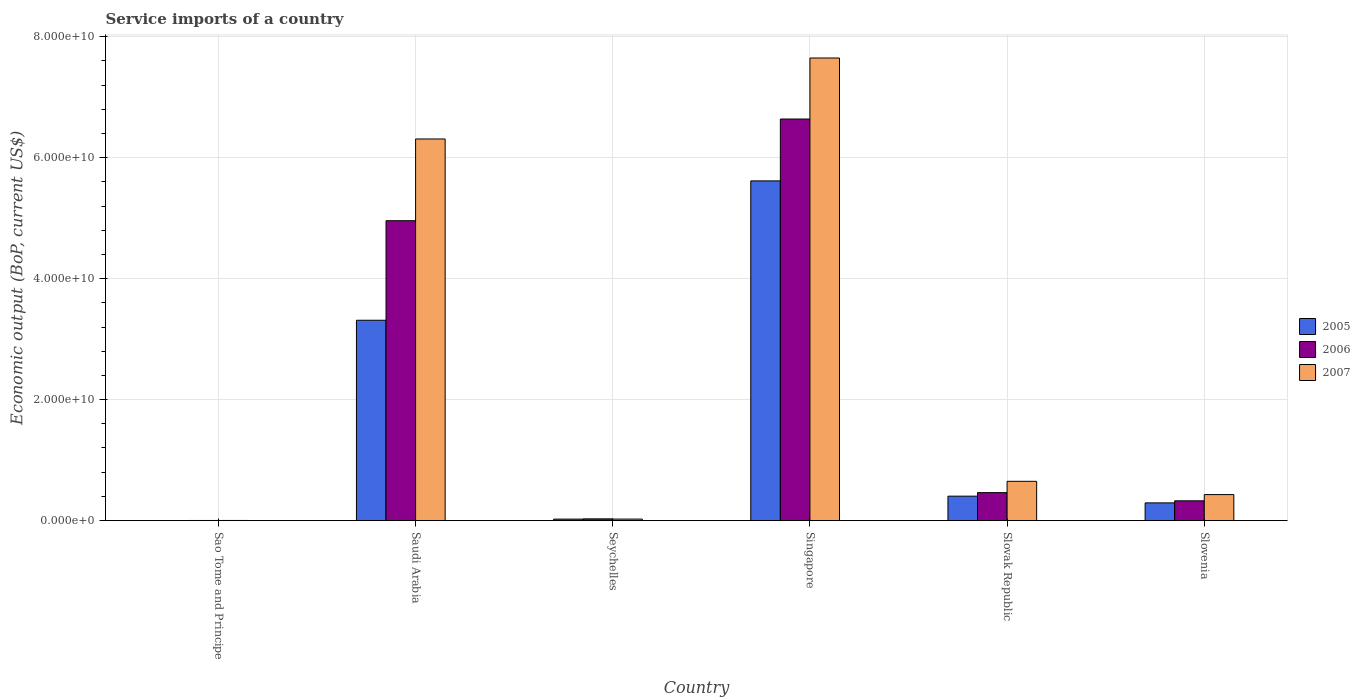How many groups of bars are there?
Ensure brevity in your answer.  6. Are the number of bars on each tick of the X-axis equal?
Give a very brief answer. Yes. What is the label of the 6th group of bars from the left?
Make the answer very short. Slovenia. In how many cases, is the number of bars for a given country not equal to the number of legend labels?
Offer a very short reply. 0. What is the service imports in 2005 in Seychelles?
Provide a succinct answer. 2.40e+08. Across all countries, what is the maximum service imports in 2005?
Ensure brevity in your answer.  5.62e+1. Across all countries, what is the minimum service imports in 2007?
Provide a succinct answer. 1.87e+07. In which country was the service imports in 2006 maximum?
Provide a succinct answer. Singapore. In which country was the service imports in 2006 minimum?
Provide a succinct answer. Sao Tome and Principe. What is the total service imports in 2006 in the graph?
Your response must be concise. 1.24e+11. What is the difference between the service imports in 2006 in Seychelles and that in Slovak Republic?
Your answer should be very brief. -4.34e+09. What is the difference between the service imports in 2007 in Slovak Republic and the service imports in 2005 in Seychelles?
Provide a succinct answer. 6.25e+09. What is the average service imports in 2005 per country?
Give a very brief answer. 1.61e+1. What is the difference between the service imports of/in 2005 and service imports of/in 2006 in Saudi Arabia?
Ensure brevity in your answer.  -1.65e+1. What is the ratio of the service imports in 2006 in Saudi Arabia to that in Slovenia?
Provide a short and direct response. 15.18. Is the difference between the service imports in 2005 in Saudi Arabia and Singapore greater than the difference between the service imports in 2006 in Saudi Arabia and Singapore?
Provide a succinct answer. No. What is the difference between the highest and the second highest service imports in 2005?
Make the answer very short. -2.91e+1. What is the difference between the highest and the lowest service imports in 2006?
Ensure brevity in your answer.  6.64e+1. What does the 1st bar from the right in Slovenia represents?
Provide a short and direct response. 2007. Are all the bars in the graph horizontal?
Offer a very short reply. No. How many countries are there in the graph?
Provide a short and direct response. 6. What is the difference between two consecutive major ticks on the Y-axis?
Your answer should be very brief. 2.00e+1. Are the values on the major ticks of Y-axis written in scientific E-notation?
Your answer should be very brief. Yes. Does the graph contain any zero values?
Offer a very short reply. No. How many legend labels are there?
Provide a succinct answer. 3. How are the legend labels stacked?
Keep it short and to the point. Vertical. What is the title of the graph?
Give a very brief answer. Service imports of a country. Does "1994" appear as one of the legend labels in the graph?
Provide a short and direct response. No. What is the label or title of the Y-axis?
Provide a succinct answer. Economic output (BoP, current US$). What is the Economic output (BoP, current US$) in 2005 in Sao Tome and Principe?
Provide a short and direct response. 1.11e+07. What is the Economic output (BoP, current US$) of 2006 in Sao Tome and Principe?
Ensure brevity in your answer.  1.78e+07. What is the Economic output (BoP, current US$) in 2007 in Sao Tome and Principe?
Offer a terse response. 1.87e+07. What is the Economic output (BoP, current US$) in 2005 in Saudi Arabia?
Provide a succinct answer. 3.31e+1. What is the Economic output (BoP, current US$) of 2006 in Saudi Arabia?
Make the answer very short. 4.96e+1. What is the Economic output (BoP, current US$) in 2007 in Saudi Arabia?
Provide a short and direct response. 6.31e+1. What is the Economic output (BoP, current US$) of 2005 in Seychelles?
Your answer should be very brief. 2.40e+08. What is the Economic output (BoP, current US$) of 2006 in Seychelles?
Make the answer very short. 2.83e+08. What is the Economic output (BoP, current US$) in 2007 in Seychelles?
Your answer should be compact. 2.47e+08. What is the Economic output (BoP, current US$) in 2005 in Singapore?
Make the answer very short. 5.62e+1. What is the Economic output (BoP, current US$) of 2006 in Singapore?
Provide a succinct answer. 6.64e+1. What is the Economic output (BoP, current US$) of 2007 in Singapore?
Keep it short and to the point. 7.65e+1. What is the Economic output (BoP, current US$) in 2005 in Slovak Republic?
Provide a succinct answer. 4.04e+09. What is the Economic output (BoP, current US$) in 2006 in Slovak Republic?
Give a very brief answer. 4.62e+09. What is the Economic output (BoP, current US$) of 2007 in Slovak Republic?
Make the answer very short. 6.49e+09. What is the Economic output (BoP, current US$) in 2005 in Slovenia?
Give a very brief answer. 2.93e+09. What is the Economic output (BoP, current US$) in 2006 in Slovenia?
Make the answer very short. 3.27e+09. What is the Economic output (BoP, current US$) of 2007 in Slovenia?
Your answer should be very brief. 4.30e+09. Across all countries, what is the maximum Economic output (BoP, current US$) of 2005?
Ensure brevity in your answer.  5.62e+1. Across all countries, what is the maximum Economic output (BoP, current US$) of 2006?
Your answer should be compact. 6.64e+1. Across all countries, what is the maximum Economic output (BoP, current US$) of 2007?
Offer a terse response. 7.65e+1. Across all countries, what is the minimum Economic output (BoP, current US$) in 2005?
Ensure brevity in your answer.  1.11e+07. Across all countries, what is the minimum Economic output (BoP, current US$) in 2006?
Give a very brief answer. 1.78e+07. Across all countries, what is the minimum Economic output (BoP, current US$) of 2007?
Ensure brevity in your answer.  1.87e+07. What is the total Economic output (BoP, current US$) of 2005 in the graph?
Offer a terse response. 9.65e+1. What is the total Economic output (BoP, current US$) in 2006 in the graph?
Make the answer very short. 1.24e+11. What is the total Economic output (BoP, current US$) of 2007 in the graph?
Give a very brief answer. 1.51e+11. What is the difference between the Economic output (BoP, current US$) in 2005 in Sao Tome and Principe and that in Saudi Arabia?
Make the answer very short. -3.31e+1. What is the difference between the Economic output (BoP, current US$) in 2006 in Sao Tome and Principe and that in Saudi Arabia?
Your response must be concise. -4.96e+1. What is the difference between the Economic output (BoP, current US$) of 2007 in Sao Tome and Principe and that in Saudi Arabia?
Offer a terse response. -6.31e+1. What is the difference between the Economic output (BoP, current US$) of 2005 in Sao Tome and Principe and that in Seychelles?
Ensure brevity in your answer.  -2.29e+08. What is the difference between the Economic output (BoP, current US$) in 2006 in Sao Tome and Principe and that in Seychelles?
Ensure brevity in your answer.  -2.65e+08. What is the difference between the Economic output (BoP, current US$) in 2007 in Sao Tome and Principe and that in Seychelles?
Your response must be concise. -2.28e+08. What is the difference between the Economic output (BoP, current US$) in 2005 in Sao Tome and Principe and that in Singapore?
Provide a succinct answer. -5.62e+1. What is the difference between the Economic output (BoP, current US$) in 2006 in Sao Tome and Principe and that in Singapore?
Give a very brief answer. -6.64e+1. What is the difference between the Economic output (BoP, current US$) of 2007 in Sao Tome and Principe and that in Singapore?
Your answer should be very brief. -7.65e+1. What is the difference between the Economic output (BoP, current US$) in 2005 in Sao Tome and Principe and that in Slovak Republic?
Provide a short and direct response. -4.02e+09. What is the difference between the Economic output (BoP, current US$) of 2006 in Sao Tome and Principe and that in Slovak Republic?
Offer a terse response. -4.60e+09. What is the difference between the Economic output (BoP, current US$) of 2007 in Sao Tome and Principe and that in Slovak Republic?
Offer a terse response. -6.47e+09. What is the difference between the Economic output (BoP, current US$) in 2005 in Sao Tome and Principe and that in Slovenia?
Your answer should be very brief. -2.91e+09. What is the difference between the Economic output (BoP, current US$) of 2006 in Sao Tome and Principe and that in Slovenia?
Your response must be concise. -3.25e+09. What is the difference between the Economic output (BoP, current US$) in 2007 in Sao Tome and Principe and that in Slovenia?
Keep it short and to the point. -4.28e+09. What is the difference between the Economic output (BoP, current US$) of 2005 in Saudi Arabia and that in Seychelles?
Your answer should be compact. 3.29e+1. What is the difference between the Economic output (BoP, current US$) in 2006 in Saudi Arabia and that in Seychelles?
Ensure brevity in your answer.  4.93e+1. What is the difference between the Economic output (BoP, current US$) in 2007 in Saudi Arabia and that in Seychelles?
Your answer should be compact. 6.28e+1. What is the difference between the Economic output (BoP, current US$) in 2005 in Saudi Arabia and that in Singapore?
Keep it short and to the point. -2.30e+1. What is the difference between the Economic output (BoP, current US$) of 2006 in Saudi Arabia and that in Singapore?
Give a very brief answer. -1.68e+1. What is the difference between the Economic output (BoP, current US$) in 2007 in Saudi Arabia and that in Singapore?
Offer a terse response. -1.34e+1. What is the difference between the Economic output (BoP, current US$) of 2005 in Saudi Arabia and that in Slovak Republic?
Provide a succinct answer. 2.91e+1. What is the difference between the Economic output (BoP, current US$) of 2006 in Saudi Arabia and that in Slovak Republic?
Offer a terse response. 4.50e+1. What is the difference between the Economic output (BoP, current US$) in 2007 in Saudi Arabia and that in Slovak Republic?
Make the answer very short. 5.66e+1. What is the difference between the Economic output (BoP, current US$) of 2005 in Saudi Arabia and that in Slovenia?
Your response must be concise. 3.02e+1. What is the difference between the Economic output (BoP, current US$) of 2006 in Saudi Arabia and that in Slovenia?
Your answer should be compact. 4.63e+1. What is the difference between the Economic output (BoP, current US$) of 2007 in Saudi Arabia and that in Slovenia?
Provide a short and direct response. 5.88e+1. What is the difference between the Economic output (BoP, current US$) in 2005 in Seychelles and that in Singapore?
Ensure brevity in your answer.  -5.59e+1. What is the difference between the Economic output (BoP, current US$) in 2006 in Seychelles and that in Singapore?
Your answer should be very brief. -6.61e+1. What is the difference between the Economic output (BoP, current US$) of 2007 in Seychelles and that in Singapore?
Provide a succinct answer. -7.62e+1. What is the difference between the Economic output (BoP, current US$) in 2005 in Seychelles and that in Slovak Republic?
Give a very brief answer. -3.80e+09. What is the difference between the Economic output (BoP, current US$) of 2006 in Seychelles and that in Slovak Republic?
Your response must be concise. -4.34e+09. What is the difference between the Economic output (BoP, current US$) of 2007 in Seychelles and that in Slovak Republic?
Your answer should be very brief. -6.24e+09. What is the difference between the Economic output (BoP, current US$) of 2005 in Seychelles and that in Slovenia?
Offer a very short reply. -2.69e+09. What is the difference between the Economic output (BoP, current US$) of 2006 in Seychelles and that in Slovenia?
Give a very brief answer. -2.98e+09. What is the difference between the Economic output (BoP, current US$) in 2007 in Seychelles and that in Slovenia?
Offer a terse response. -4.05e+09. What is the difference between the Economic output (BoP, current US$) in 2005 in Singapore and that in Slovak Republic?
Offer a very short reply. 5.21e+1. What is the difference between the Economic output (BoP, current US$) in 2006 in Singapore and that in Slovak Republic?
Give a very brief answer. 6.18e+1. What is the difference between the Economic output (BoP, current US$) in 2007 in Singapore and that in Slovak Republic?
Make the answer very short. 7.00e+1. What is the difference between the Economic output (BoP, current US$) of 2005 in Singapore and that in Slovenia?
Keep it short and to the point. 5.32e+1. What is the difference between the Economic output (BoP, current US$) in 2006 in Singapore and that in Slovenia?
Ensure brevity in your answer.  6.31e+1. What is the difference between the Economic output (BoP, current US$) in 2007 in Singapore and that in Slovenia?
Keep it short and to the point. 7.22e+1. What is the difference between the Economic output (BoP, current US$) of 2005 in Slovak Republic and that in Slovenia?
Make the answer very short. 1.11e+09. What is the difference between the Economic output (BoP, current US$) in 2006 in Slovak Republic and that in Slovenia?
Your answer should be very brief. 1.35e+09. What is the difference between the Economic output (BoP, current US$) of 2007 in Slovak Republic and that in Slovenia?
Provide a succinct answer. 2.19e+09. What is the difference between the Economic output (BoP, current US$) in 2005 in Sao Tome and Principe and the Economic output (BoP, current US$) in 2006 in Saudi Arabia?
Offer a terse response. -4.96e+1. What is the difference between the Economic output (BoP, current US$) in 2005 in Sao Tome and Principe and the Economic output (BoP, current US$) in 2007 in Saudi Arabia?
Ensure brevity in your answer.  -6.31e+1. What is the difference between the Economic output (BoP, current US$) of 2006 in Sao Tome and Principe and the Economic output (BoP, current US$) of 2007 in Saudi Arabia?
Your response must be concise. -6.31e+1. What is the difference between the Economic output (BoP, current US$) of 2005 in Sao Tome and Principe and the Economic output (BoP, current US$) of 2006 in Seychelles?
Give a very brief answer. -2.72e+08. What is the difference between the Economic output (BoP, current US$) in 2005 in Sao Tome and Principe and the Economic output (BoP, current US$) in 2007 in Seychelles?
Give a very brief answer. -2.36e+08. What is the difference between the Economic output (BoP, current US$) in 2006 in Sao Tome and Principe and the Economic output (BoP, current US$) in 2007 in Seychelles?
Provide a succinct answer. -2.29e+08. What is the difference between the Economic output (BoP, current US$) of 2005 in Sao Tome and Principe and the Economic output (BoP, current US$) of 2006 in Singapore?
Offer a terse response. -6.64e+1. What is the difference between the Economic output (BoP, current US$) in 2005 in Sao Tome and Principe and the Economic output (BoP, current US$) in 2007 in Singapore?
Offer a very short reply. -7.65e+1. What is the difference between the Economic output (BoP, current US$) of 2006 in Sao Tome and Principe and the Economic output (BoP, current US$) of 2007 in Singapore?
Make the answer very short. -7.65e+1. What is the difference between the Economic output (BoP, current US$) in 2005 in Sao Tome and Principe and the Economic output (BoP, current US$) in 2006 in Slovak Republic?
Make the answer very short. -4.61e+09. What is the difference between the Economic output (BoP, current US$) in 2005 in Sao Tome and Principe and the Economic output (BoP, current US$) in 2007 in Slovak Republic?
Your answer should be very brief. -6.48e+09. What is the difference between the Economic output (BoP, current US$) of 2006 in Sao Tome and Principe and the Economic output (BoP, current US$) of 2007 in Slovak Republic?
Ensure brevity in your answer.  -6.47e+09. What is the difference between the Economic output (BoP, current US$) in 2005 in Sao Tome and Principe and the Economic output (BoP, current US$) in 2006 in Slovenia?
Give a very brief answer. -3.26e+09. What is the difference between the Economic output (BoP, current US$) in 2005 in Sao Tome and Principe and the Economic output (BoP, current US$) in 2007 in Slovenia?
Provide a succinct answer. -4.29e+09. What is the difference between the Economic output (BoP, current US$) of 2006 in Sao Tome and Principe and the Economic output (BoP, current US$) of 2007 in Slovenia?
Provide a succinct answer. -4.28e+09. What is the difference between the Economic output (BoP, current US$) in 2005 in Saudi Arabia and the Economic output (BoP, current US$) in 2006 in Seychelles?
Your answer should be compact. 3.28e+1. What is the difference between the Economic output (BoP, current US$) of 2005 in Saudi Arabia and the Economic output (BoP, current US$) of 2007 in Seychelles?
Your answer should be very brief. 3.29e+1. What is the difference between the Economic output (BoP, current US$) of 2006 in Saudi Arabia and the Economic output (BoP, current US$) of 2007 in Seychelles?
Give a very brief answer. 4.93e+1. What is the difference between the Economic output (BoP, current US$) in 2005 in Saudi Arabia and the Economic output (BoP, current US$) in 2006 in Singapore?
Your answer should be very brief. -3.33e+1. What is the difference between the Economic output (BoP, current US$) in 2005 in Saudi Arabia and the Economic output (BoP, current US$) in 2007 in Singapore?
Your response must be concise. -4.34e+1. What is the difference between the Economic output (BoP, current US$) in 2006 in Saudi Arabia and the Economic output (BoP, current US$) in 2007 in Singapore?
Keep it short and to the point. -2.69e+1. What is the difference between the Economic output (BoP, current US$) of 2005 in Saudi Arabia and the Economic output (BoP, current US$) of 2006 in Slovak Republic?
Give a very brief answer. 2.85e+1. What is the difference between the Economic output (BoP, current US$) of 2005 in Saudi Arabia and the Economic output (BoP, current US$) of 2007 in Slovak Republic?
Offer a very short reply. 2.66e+1. What is the difference between the Economic output (BoP, current US$) in 2006 in Saudi Arabia and the Economic output (BoP, current US$) in 2007 in Slovak Republic?
Your answer should be compact. 4.31e+1. What is the difference between the Economic output (BoP, current US$) in 2005 in Saudi Arabia and the Economic output (BoP, current US$) in 2006 in Slovenia?
Offer a very short reply. 2.99e+1. What is the difference between the Economic output (BoP, current US$) of 2005 in Saudi Arabia and the Economic output (BoP, current US$) of 2007 in Slovenia?
Offer a very short reply. 2.88e+1. What is the difference between the Economic output (BoP, current US$) in 2006 in Saudi Arabia and the Economic output (BoP, current US$) in 2007 in Slovenia?
Offer a terse response. 4.53e+1. What is the difference between the Economic output (BoP, current US$) of 2005 in Seychelles and the Economic output (BoP, current US$) of 2006 in Singapore?
Your answer should be compact. -6.62e+1. What is the difference between the Economic output (BoP, current US$) of 2005 in Seychelles and the Economic output (BoP, current US$) of 2007 in Singapore?
Offer a terse response. -7.62e+1. What is the difference between the Economic output (BoP, current US$) in 2006 in Seychelles and the Economic output (BoP, current US$) in 2007 in Singapore?
Offer a very short reply. -7.62e+1. What is the difference between the Economic output (BoP, current US$) in 2005 in Seychelles and the Economic output (BoP, current US$) in 2006 in Slovak Republic?
Give a very brief answer. -4.38e+09. What is the difference between the Economic output (BoP, current US$) of 2005 in Seychelles and the Economic output (BoP, current US$) of 2007 in Slovak Republic?
Your response must be concise. -6.25e+09. What is the difference between the Economic output (BoP, current US$) in 2006 in Seychelles and the Economic output (BoP, current US$) in 2007 in Slovak Republic?
Provide a short and direct response. -6.21e+09. What is the difference between the Economic output (BoP, current US$) in 2005 in Seychelles and the Economic output (BoP, current US$) in 2006 in Slovenia?
Provide a succinct answer. -3.03e+09. What is the difference between the Economic output (BoP, current US$) in 2005 in Seychelles and the Economic output (BoP, current US$) in 2007 in Slovenia?
Offer a terse response. -4.06e+09. What is the difference between the Economic output (BoP, current US$) of 2006 in Seychelles and the Economic output (BoP, current US$) of 2007 in Slovenia?
Keep it short and to the point. -4.01e+09. What is the difference between the Economic output (BoP, current US$) in 2005 in Singapore and the Economic output (BoP, current US$) in 2006 in Slovak Republic?
Make the answer very short. 5.15e+1. What is the difference between the Economic output (BoP, current US$) in 2005 in Singapore and the Economic output (BoP, current US$) in 2007 in Slovak Republic?
Provide a succinct answer. 4.97e+1. What is the difference between the Economic output (BoP, current US$) in 2006 in Singapore and the Economic output (BoP, current US$) in 2007 in Slovak Republic?
Make the answer very short. 5.99e+1. What is the difference between the Economic output (BoP, current US$) of 2005 in Singapore and the Economic output (BoP, current US$) of 2006 in Slovenia?
Your answer should be very brief. 5.29e+1. What is the difference between the Economic output (BoP, current US$) of 2005 in Singapore and the Economic output (BoP, current US$) of 2007 in Slovenia?
Provide a short and direct response. 5.19e+1. What is the difference between the Economic output (BoP, current US$) of 2006 in Singapore and the Economic output (BoP, current US$) of 2007 in Slovenia?
Provide a short and direct response. 6.21e+1. What is the difference between the Economic output (BoP, current US$) of 2005 in Slovak Republic and the Economic output (BoP, current US$) of 2006 in Slovenia?
Your answer should be very brief. 7.69e+08. What is the difference between the Economic output (BoP, current US$) in 2005 in Slovak Republic and the Economic output (BoP, current US$) in 2007 in Slovenia?
Ensure brevity in your answer.  -2.62e+08. What is the difference between the Economic output (BoP, current US$) of 2006 in Slovak Republic and the Economic output (BoP, current US$) of 2007 in Slovenia?
Your answer should be very brief. 3.23e+08. What is the average Economic output (BoP, current US$) in 2005 per country?
Make the answer very short. 1.61e+1. What is the average Economic output (BoP, current US$) in 2006 per country?
Your answer should be very brief. 2.07e+1. What is the average Economic output (BoP, current US$) in 2007 per country?
Offer a very short reply. 2.51e+1. What is the difference between the Economic output (BoP, current US$) of 2005 and Economic output (BoP, current US$) of 2006 in Sao Tome and Principe?
Offer a very short reply. -6.70e+06. What is the difference between the Economic output (BoP, current US$) in 2005 and Economic output (BoP, current US$) in 2007 in Sao Tome and Principe?
Offer a very short reply. -7.61e+06. What is the difference between the Economic output (BoP, current US$) in 2006 and Economic output (BoP, current US$) in 2007 in Sao Tome and Principe?
Give a very brief answer. -9.06e+05. What is the difference between the Economic output (BoP, current US$) in 2005 and Economic output (BoP, current US$) in 2006 in Saudi Arabia?
Give a very brief answer. -1.65e+1. What is the difference between the Economic output (BoP, current US$) in 2005 and Economic output (BoP, current US$) in 2007 in Saudi Arabia?
Give a very brief answer. -3.00e+1. What is the difference between the Economic output (BoP, current US$) in 2006 and Economic output (BoP, current US$) in 2007 in Saudi Arabia?
Make the answer very short. -1.35e+1. What is the difference between the Economic output (BoP, current US$) in 2005 and Economic output (BoP, current US$) in 2006 in Seychelles?
Your answer should be very brief. -4.24e+07. What is the difference between the Economic output (BoP, current US$) of 2005 and Economic output (BoP, current US$) of 2007 in Seychelles?
Your response must be concise. -6.43e+06. What is the difference between the Economic output (BoP, current US$) in 2006 and Economic output (BoP, current US$) in 2007 in Seychelles?
Offer a terse response. 3.60e+07. What is the difference between the Economic output (BoP, current US$) of 2005 and Economic output (BoP, current US$) of 2006 in Singapore?
Your answer should be compact. -1.02e+1. What is the difference between the Economic output (BoP, current US$) of 2005 and Economic output (BoP, current US$) of 2007 in Singapore?
Make the answer very short. -2.03e+1. What is the difference between the Economic output (BoP, current US$) of 2006 and Economic output (BoP, current US$) of 2007 in Singapore?
Keep it short and to the point. -1.01e+1. What is the difference between the Economic output (BoP, current US$) in 2005 and Economic output (BoP, current US$) in 2006 in Slovak Republic?
Offer a very short reply. -5.85e+08. What is the difference between the Economic output (BoP, current US$) in 2005 and Economic output (BoP, current US$) in 2007 in Slovak Republic?
Provide a succinct answer. -2.46e+09. What is the difference between the Economic output (BoP, current US$) in 2006 and Economic output (BoP, current US$) in 2007 in Slovak Republic?
Make the answer very short. -1.87e+09. What is the difference between the Economic output (BoP, current US$) in 2005 and Economic output (BoP, current US$) in 2006 in Slovenia?
Provide a succinct answer. -3.41e+08. What is the difference between the Economic output (BoP, current US$) in 2005 and Economic output (BoP, current US$) in 2007 in Slovenia?
Make the answer very short. -1.37e+09. What is the difference between the Economic output (BoP, current US$) in 2006 and Economic output (BoP, current US$) in 2007 in Slovenia?
Provide a short and direct response. -1.03e+09. What is the ratio of the Economic output (BoP, current US$) of 2005 in Sao Tome and Principe to that in Saudi Arabia?
Offer a terse response. 0. What is the ratio of the Economic output (BoP, current US$) of 2007 in Sao Tome and Principe to that in Saudi Arabia?
Keep it short and to the point. 0. What is the ratio of the Economic output (BoP, current US$) of 2005 in Sao Tome and Principe to that in Seychelles?
Your answer should be compact. 0.05. What is the ratio of the Economic output (BoP, current US$) in 2006 in Sao Tome and Principe to that in Seychelles?
Provide a short and direct response. 0.06. What is the ratio of the Economic output (BoP, current US$) of 2007 in Sao Tome and Principe to that in Seychelles?
Make the answer very short. 0.08. What is the ratio of the Economic output (BoP, current US$) in 2005 in Sao Tome and Principe to that in Slovak Republic?
Your answer should be compact. 0. What is the ratio of the Economic output (BoP, current US$) in 2006 in Sao Tome and Principe to that in Slovak Republic?
Give a very brief answer. 0. What is the ratio of the Economic output (BoP, current US$) in 2007 in Sao Tome and Principe to that in Slovak Republic?
Make the answer very short. 0. What is the ratio of the Economic output (BoP, current US$) of 2005 in Sao Tome and Principe to that in Slovenia?
Your answer should be compact. 0. What is the ratio of the Economic output (BoP, current US$) of 2006 in Sao Tome and Principe to that in Slovenia?
Offer a very short reply. 0.01. What is the ratio of the Economic output (BoP, current US$) of 2007 in Sao Tome and Principe to that in Slovenia?
Give a very brief answer. 0. What is the ratio of the Economic output (BoP, current US$) in 2005 in Saudi Arabia to that in Seychelles?
Make the answer very short. 137.81. What is the ratio of the Economic output (BoP, current US$) in 2006 in Saudi Arabia to that in Seychelles?
Keep it short and to the point. 175.36. What is the ratio of the Economic output (BoP, current US$) of 2007 in Saudi Arabia to that in Seychelles?
Your response must be concise. 255.68. What is the ratio of the Economic output (BoP, current US$) in 2005 in Saudi Arabia to that in Singapore?
Give a very brief answer. 0.59. What is the ratio of the Economic output (BoP, current US$) in 2006 in Saudi Arabia to that in Singapore?
Ensure brevity in your answer.  0.75. What is the ratio of the Economic output (BoP, current US$) in 2007 in Saudi Arabia to that in Singapore?
Make the answer very short. 0.82. What is the ratio of the Economic output (BoP, current US$) in 2005 in Saudi Arabia to that in Slovak Republic?
Offer a very short reply. 8.21. What is the ratio of the Economic output (BoP, current US$) of 2006 in Saudi Arabia to that in Slovak Republic?
Your response must be concise. 10.73. What is the ratio of the Economic output (BoP, current US$) of 2007 in Saudi Arabia to that in Slovak Republic?
Your answer should be very brief. 9.72. What is the ratio of the Economic output (BoP, current US$) of 2005 in Saudi Arabia to that in Slovenia?
Ensure brevity in your answer.  11.32. What is the ratio of the Economic output (BoP, current US$) of 2006 in Saudi Arabia to that in Slovenia?
Give a very brief answer. 15.18. What is the ratio of the Economic output (BoP, current US$) of 2007 in Saudi Arabia to that in Slovenia?
Make the answer very short. 14.68. What is the ratio of the Economic output (BoP, current US$) in 2005 in Seychelles to that in Singapore?
Your answer should be very brief. 0. What is the ratio of the Economic output (BoP, current US$) of 2006 in Seychelles to that in Singapore?
Your answer should be very brief. 0. What is the ratio of the Economic output (BoP, current US$) of 2007 in Seychelles to that in Singapore?
Your answer should be very brief. 0. What is the ratio of the Economic output (BoP, current US$) in 2005 in Seychelles to that in Slovak Republic?
Ensure brevity in your answer.  0.06. What is the ratio of the Economic output (BoP, current US$) in 2006 in Seychelles to that in Slovak Republic?
Your answer should be compact. 0.06. What is the ratio of the Economic output (BoP, current US$) in 2007 in Seychelles to that in Slovak Republic?
Offer a very short reply. 0.04. What is the ratio of the Economic output (BoP, current US$) of 2005 in Seychelles to that in Slovenia?
Your response must be concise. 0.08. What is the ratio of the Economic output (BoP, current US$) of 2006 in Seychelles to that in Slovenia?
Offer a terse response. 0.09. What is the ratio of the Economic output (BoP, current US$) of 2007 in Seychelles to that in Slovenia?
Provide a short and direct response. 0.06. What is the ratio of the Economic output (BoP, current US$) in 2005 in Singapore to that in Slovak Republic?
Provide a short and direct response. 13.92. What is the ratio of the Economic output (BoP, current US$) of 2006 in Singapore to that in Slovak Republic?
Offer a very short reply. 14.37. What is the ratio of the Economic output (BoP, current US$) in 2007 in Singapore to that in Slovak Republic?
Offer a very short reply. 11.78. What is the ratio of the Economic output (BoP, current US$) of 2005 in Singapore to that in Slovenia?
Provide a succinct answer. 19.2. What is the ratio of the Economic output (BoP, current US$) in 2006 in Singapore to that in Slovenia?
Your response must be concise. 20.32. What is the ratio of the Economic output (BoP, current US$) of 2007 in Singapore to that in Slovenia?
Offer a very short reply. 17.8. What is the ratio of the Economic output (BoP, current US$) of 2005 in Slovak Republic to that in Slovenia?
Provide a succinct answer. 1.38. What is the ratio of the Economic output (BoP, current US$) in 2006 in Slovak Republic to that in Slovenia?
Your response must be concise. 1.41. What is the ratio of the Economic output (BoP, current US$) in 2007 in Slovak Republic to that in Slovenia?
Provide a succinct answer. 1.51. What is the difference between the highest and the second highest Economic output (BoP, current US$) in 2005?
Provide a short and direct response. 2.30e+1. What is the difference between the highest and the second highest Economic output (BoP, current US$) of 2006?
Provide a succinct answer. 1.68e+1. What is the difference between the highest and the second highest Economic output (BoP, current US$) of 2007?
Give a very brief answer. 1.34e+1. What is the difference between the highest and the lowest Economic output (BoP, current US$) in 2005?
Offer a very short reply. 5.62e+1. What is the difference between the highest and the lowest Economic output (BoP, current US$) of 2006?
Ensure brevity in your answer.  6.64e+1. What is the difference between the highest and the lowest Economic output (BoP, current US$) in 2007?
Offer a terse response. 7.65e+1. 